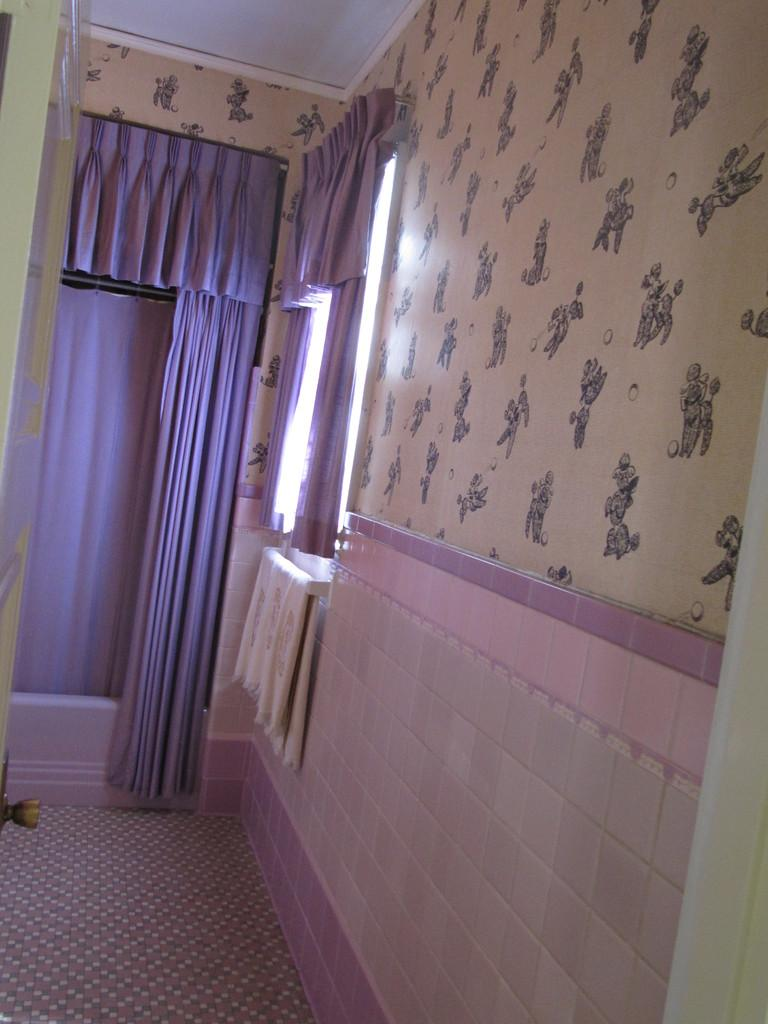What type of location is depicted in the image? The image is an inside picture of a room. What can be found on the windows in the room? There are curtains in the room. Is there a source of natural light in the room? Yes, there is a window in the room. What can be observed on the walls of the room? The wall has a design. What scientific unit is being measured in the room? There is no indication of any scientific measurements being taken in the room, as the image only shows a room with curtains, a window, and a designed wall. 